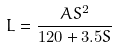Convert formula to latex. <formula><loc_0><loc_0><loc_500><loc_500>L = \frac { A S ^ { 2 } } { 1 2 0 + 3 . 5 S }</formula> 